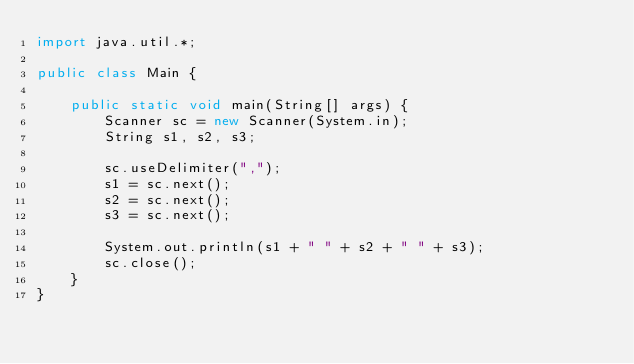<code> <loc_0><loc_0><loc_500><loc_500><_Java_>import java.util.*;

public class Main {

    public static void main(String[] args) {
        Scanner sc = new Scanner(System.in);
        String s1, s2, s3;

        sc.useDelimiter(",");
        s1 = sc.next();
        s2 = sc.next();
        s3 = sc.next();

        System.out.println(s1 + " " + s2 + " " + s3);
        sc.close();
    }
}</code> 